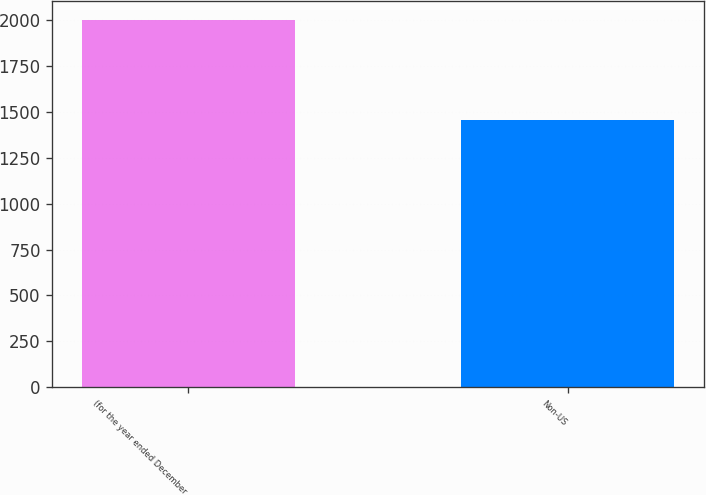<chart> <loc_0><loc_0><loc_500><loc_500><bar_chart><fcel>(for the year ended December<fcel>Non-US<nl><fcel>2005<fcel>1457<nl></chart> 